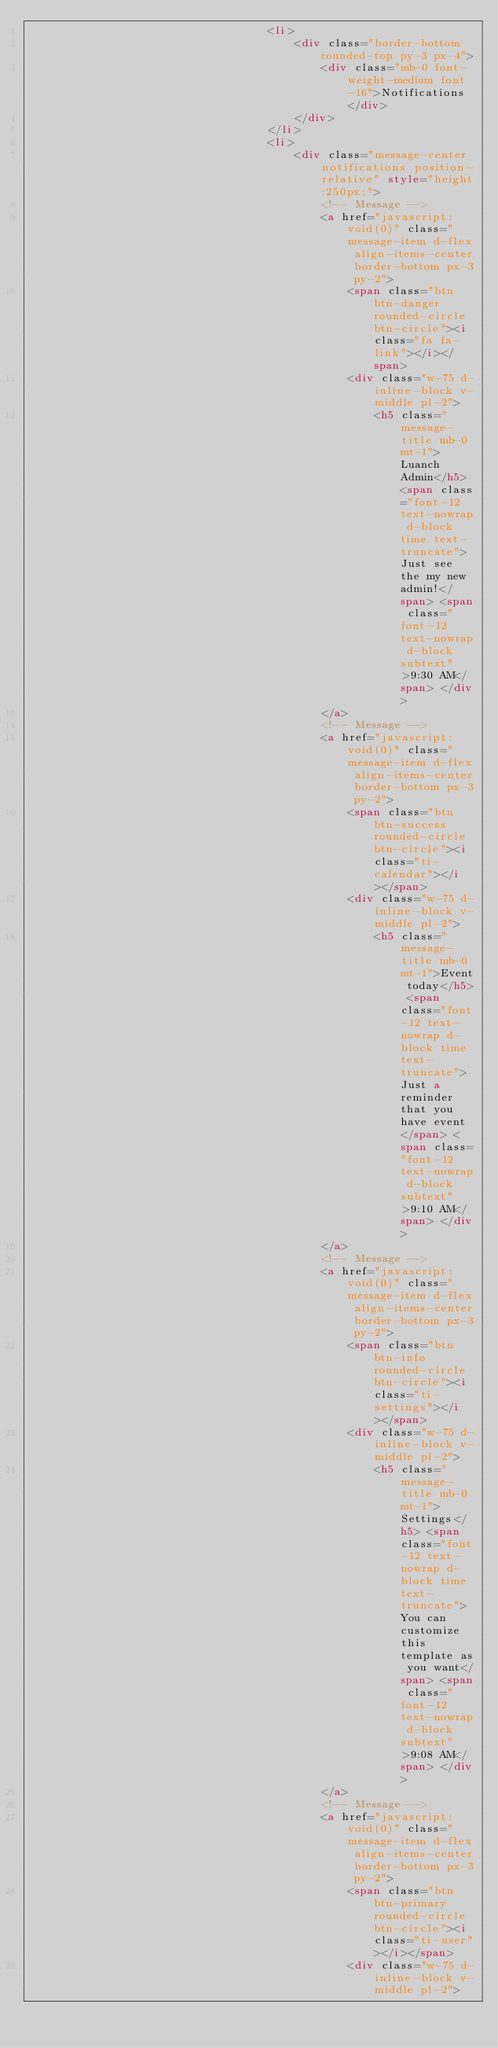<code> <loc_0><loc_0><loc_500><loc_500><_HTML_>                                    <li>
                                        <div class="border-bottom rounded-top py-3 px-4">
                                            <div class="mb-0 font-weight-medium font-16">Notifications</div>
                                        </div>
                                    </li>
                                    <li>
                                        <div class="message-center notifications position-relative" style="height:250px;">
                                            <!-- Message -->
                                            <a href="javascript:void(0)" class="message-item d-flex align-items-center border-bottom px-3 py-2">
                                                <span class="btn btn-danger rounded-circle btn-circle"><i class="fa fa-link"></i></span>
                                                <div class="w-75 d-inline-block v-middle pl-2">
                                                    <h5 class="message-title mb-0 mt-1">Luanch Admin</h5> <span class="font-12 text-nowrap d-block time text-truncate">Just see the my new admin!</span> <span class="font-12 text-nowrap d-block subtext">9:30 AM</span> </div>
                                            </a>
                                            <!-- Message -->
                                            <a href="javascript:void(0)" class="message-item d-flex align-items-center border-bottom px-3 py-2">
                                                <span class="btn btn-success rounded-circle btn-circle"><i class="ti-calendar"></i></span>
                                                <div class="w-75 d-inline-block v-middle pl-2">
                                                    <h5 class="message-title mb-0 mt-1">Event today</h5> <span class="font-12 text-nowrap d-block time text-truncate">Just a reminder that you have event</span> <span class="font-12 text-nowrap d-block subtext">9:10 AM</span> </div>
                                            </a>
                                            <!-- Message -->
                                            <a href="javascript:void(0)" class="message-item d-flex align-items-center border-bottom px-3 py-2">
                                                <span class="btn btn-info rounded-circle btn-circle"><i class="ti-settings"></i></span>
                                                <div class="w-75 d-inline-block v-middle pl-2">
                                                    <h5 class="message-title mb-0 mt-1">Settings</h5> <span class="font-12 text-nowrap d-block time text-truncate">You can customize this template as you want</span> <span class="font-12 text-nowrap d-block subtext">9:08 AM</span> </div>
                                            </a>
                                            <!-- Message -->
                                            <a href="javascript:void(0)" class="message-item d-flex align-items-center border-bottom px-3 py-2">
                                                <span class="btn btn-primary rounded-circle btn-circle"><i class="ti-user"></i></span>
                                                <div class="w-75 d-inline-block v-middle pl-2"></code> 